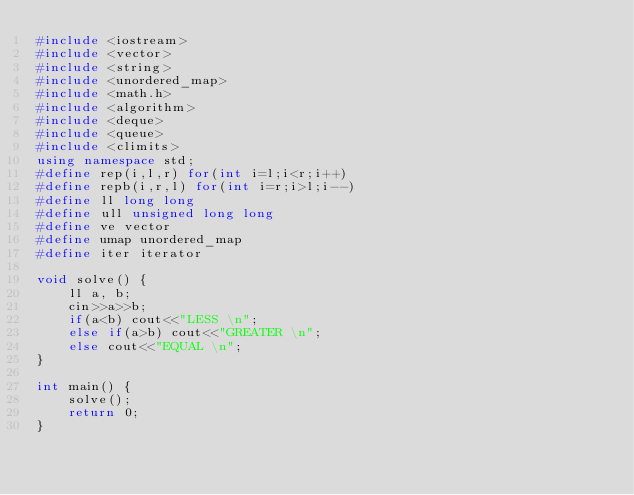Convert code to text. <code><loc_0><loc_0><loc_500><loc_500><_C++_>#include <iostream>
#include <vector>
#include <string>
#include <unordered_map>
#include <math.h>
#include <algorithm>
#include <deque>
#include <queue>
#include <climits>
using namespace std;
#define rep(i,l,r) for(int i=l;i<r;i++)
#define repb(i,r,l) for(int i=r;i>l;i--)
#define ll long long
#define ull unsigned long long
#define ve vector
#define umap unordered_map
#define iter iterator

void solve() {
    ll a, b;
    cin>>a>>b;
    if(a<b) cout<<"LESS \n";
    else if(a>b) cout<<"GREATER \n";
    else cout<<"EQUAL \n";
}

int main() {
    solve();
    return 0;
}</code> 